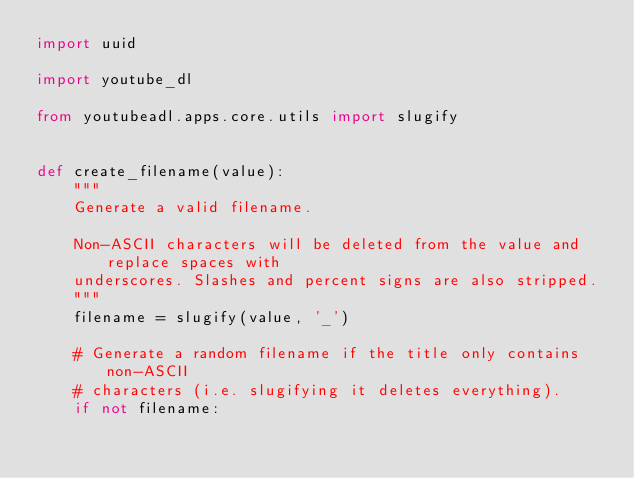Convert code to text. <code><loc_0><loc_0><loc_500><loc_500><_Python_>import uuid

import youtube_dl

from youtubeadl.apps.core.utils import slugify


def create_filename(value):
    """
    Generate a valid filename.

    Non-ASCII characters will be deleted from the value and replace spaces with
    underscores. Slashes and percent signs are also stripped.
    """
    filename = slugify(value, '_')

    # Generate a random filename if the title only contains non-ASCII
    # characters (i.e. slugifying it deletes everything).
    if not filename:</code> 